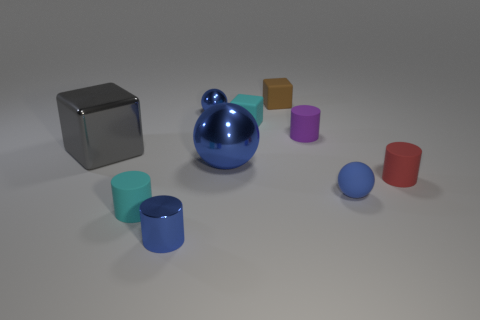Subtract all large gray metal blocks. How many blocks are left? 2 Subtract all blue cylinders. How many cylinders are left? 3 Subtract 3 cylinders. How many cylinders are left? 1 Subtract all spheres. How many objects are left? 7 Subtract all green blocks. Subtract all red cylinders. How many blocks are left? 3 Add 1 small red matte cylinders. How many small red matte cylinders are left? 2 Add 1 rubber things. How many rubber things exist? 7 Subtract 0 green cylinders. How many objects are left? 10 Subtract all tiny purple metal things. Subtract all red matte cylinders. How many objects are left? 9 